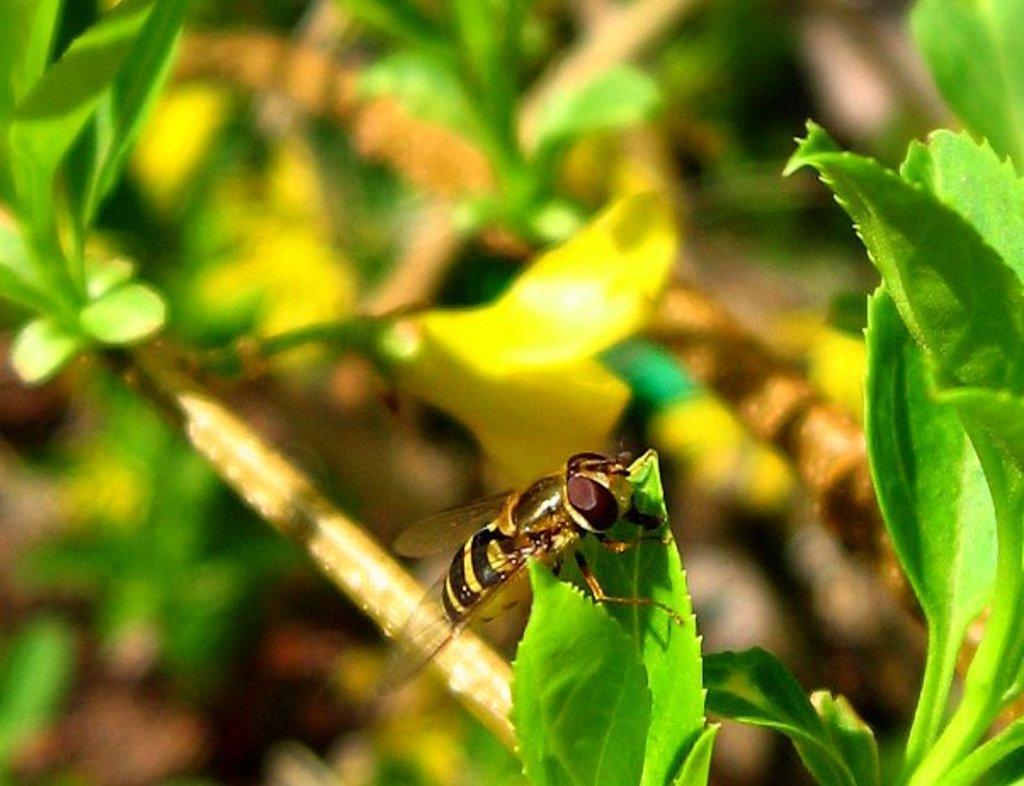How would you summarize this image in a sentence or two? In this image there is a fly on a leaf, behind the fly there are leaves and branches. 